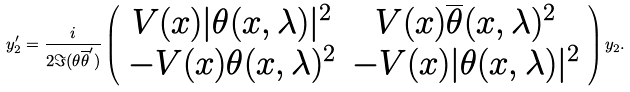<formula> <loc_0><loc_0><loc_500><loc_500>y _ { 2 } ^ { \prime } = \frac { i } { 2 \Im ( \theta \overline { \theta } ^ { \prime } ) } \left ( \begin{array} { c c } V ( x ) | \theta ( x , \lambda ) | ^ { 2 } & V ( x ) \overline { \theta } ( x , \lambda ) ^ { 2 } \\ - V ( x ) \theta ( x , \lambda ) ^ { 2 } & - V ( x ) | \theta ( x , \lambda ) | ^ { 2 } \end{array} \right ) y _ { 2 } .</formula> 